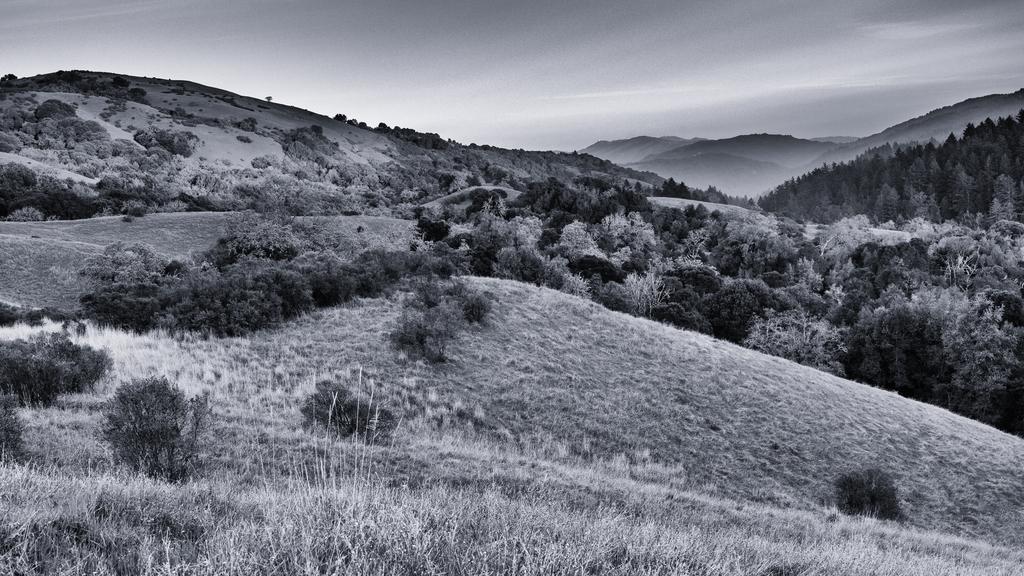Could you give a brief overview of what you see in this image? Black and white picture. In this picture we can see plants, grass, trees, hills and sky. 